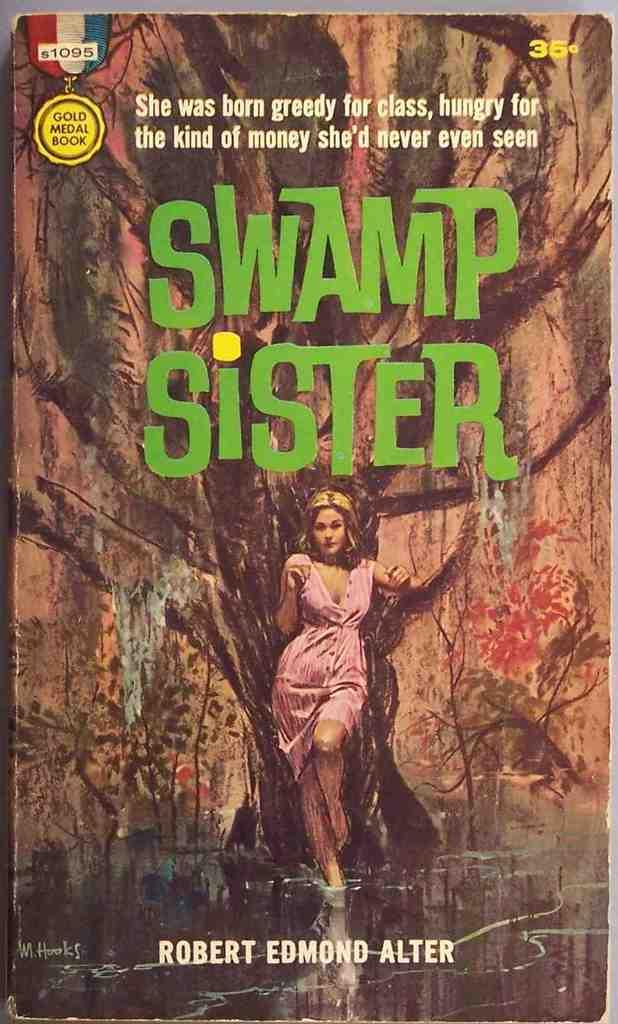What kind of sister is she?
Offer a terse response. Swamp. Who wrote this book?
Your response must be concise. Robert edmond alter. 